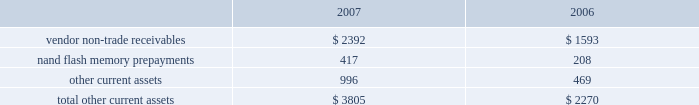Notes to consolidated financial statements ( continued ) note 2 2014financial instruments ( continued ) typically , the company hedges portions of its forecasted foreign currency exposure associated with revenue and inventory purchases over a time horizon of up to 6 months .
Derivative instruments designated as cash flow hedges must be de-designated as hedges when it is probable the forecasted hedged transaction will not occur in the initially identified time period or within a subsequent 2 month time period .
Deferred gains and losses in other comprehensive income associated with such derivative instruments are immediately reclassified into earnings in other income and expense .
Any subsequent changes in fair value of such derivative instruments are also reflected in current earnings unless they are re-designated as hedges of other transactions .
The company recognized net gains of approximately $ 672000 and $ 421000 in 2007 and 2006 , respectively , and a net loss of $ 1.6 million in 2005 in other income and expense related to the loss of hedge designation on discontinued cash flow hedges due to changes in the company 2019s forecast of future net sales and cost of sales and due to prevailing market conditions .
As of september 29 , 2007 , the company had a net deferred gain associated with cash flow hedges of approximately $ 468000 , net of taxes , substantially all of which is expected to be reclassified to earnings by the end of the second quarter of fiscal 2008 .
The net gain or loss on the effective portion of a derivative instrument designated as a net investment hedge is included in the cumulative translation adjustment account of accumulated other comprehensive income within shareholders 2019 equity .
For the years ended september 29 , 2007 and september 30 , 2006 , the company had a net loss of $ 2.6 million and a net gain of $ 7.4 million , respectively , included in the cumulative translation adjustment .
The company may also enter into foreign currency forward and option contracts to offset the foreign exchange gains and losses generated by the re-measurement of certain assets and liabilities recorded in non-functional currencies .
Changes in the fair value of these derivatives are recognized in current earnings in other income and expense as offsets to the changes in the fair value of the related assets or liabilities .
Due to currency market movements , changes in option time value can lead to increased volatility in other income and expense .
Note 3 2014consolidated financial statement details ( in millions ) other current assets .

What was the largest amount of other current assets? 
Computations: table_max(other current assets, none)
Answer: 996.0. 